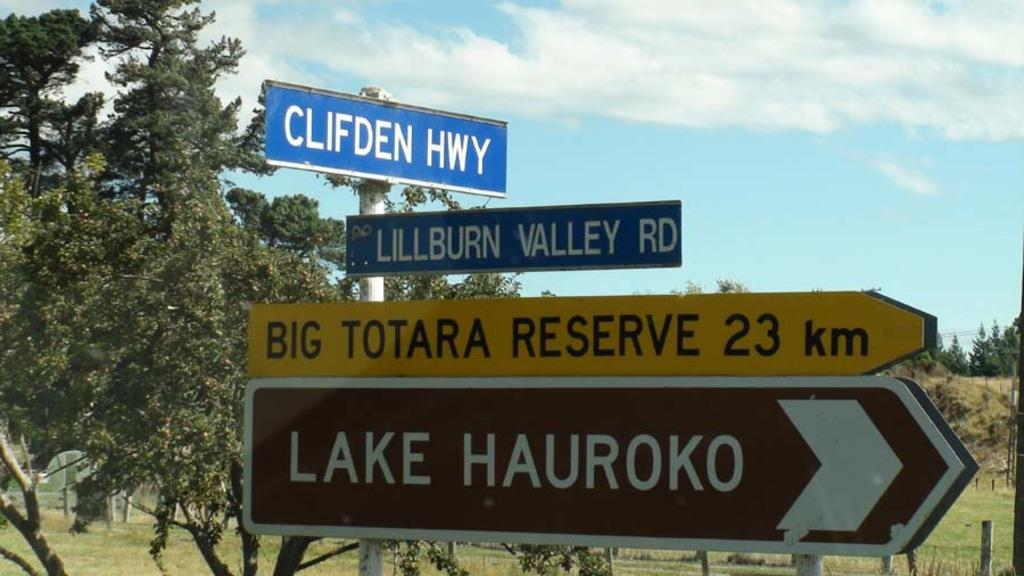<image>
Relay a brief, clear account of the picture shown. A group of street signs that say Lake Hauroko, Clifden Hwy and Lillburn Valley Rd. 